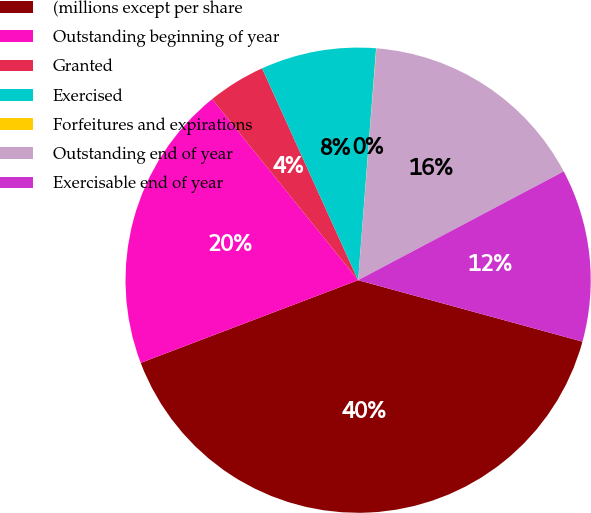Convert chart to OTSL. <chart><loc_0><loc_0><loc_500><loc_500><pie_chart><fcel>(millions except per share<fcel>Outstanding beginning of year<fcel>Granted<fcel>Exercised<fcel>Forfeitures and expirations<fcel>Outstanding end of year<fcel>Exercisable end of year<nl><fcel>39.96%<fcel>19.99%<fcel>4.02%<fcel>8.01%<fcel>0.02%<fcel>16.0%<fcel>12.0%<nl></chart> 